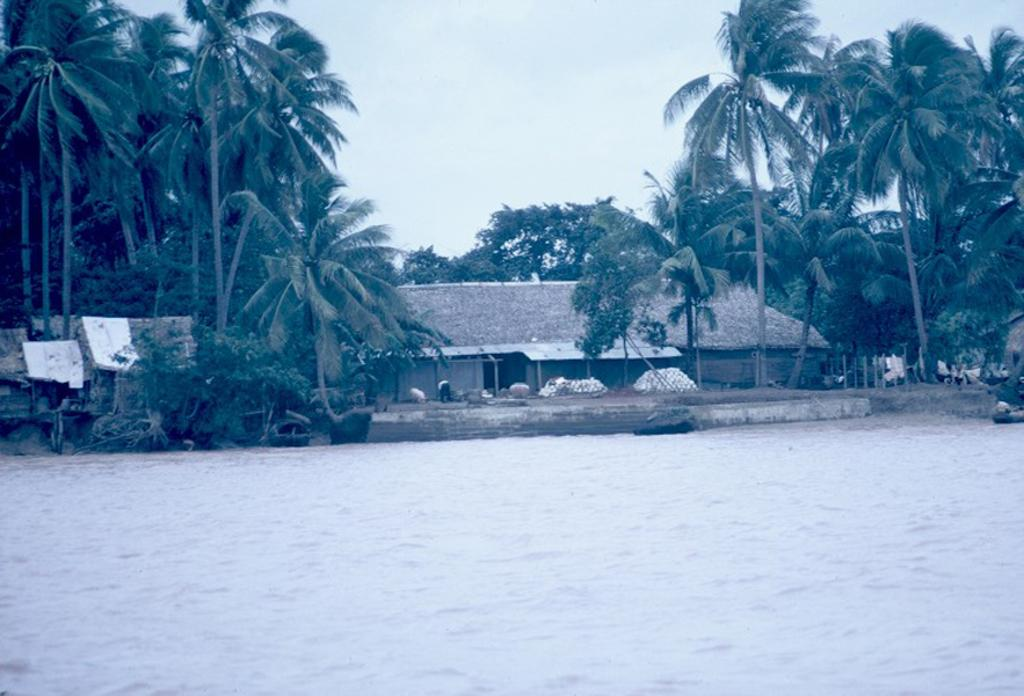What is the primary element visible in the image? There is water in the image. What can be seen in the background of the image? There are trees and a house with pillars in the background of the image. What is visible above the trees and house in the image? The sky is visible in the background of the image. What type of plastic is used to create the actor's costume in the image? There is no actor or costume present in the image; it features water, trees, a house with pillars, and the sky. 